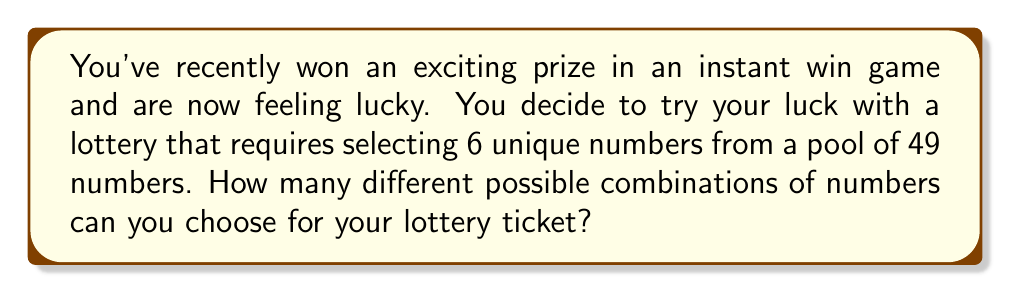Solve this math problem. Let's approach this step-by-step:

1) This is a combination problem because the order of selection doesn't matter (e.g., 1-2-3-4-5-6 is the same combination as 6-5-4-3-2-1).

2) We are selecting 6 numbers out of 49, where each number can only be chosen once.

3) The formula for combinations is:

   $$C(n,r) = \frac{n!}{r!(n-r)!}$$

   Where $n$ is the total number of items to choose from, and $r$ is the number of items being chosen.

4) In this case, $n = 49$ and $r = 6$

5) Plugging these values into our formula:

   $$C(49,6) = \frac{49!}{6!(49-6)!} = \frac{49!}{6!43!}$$

6) Expanding this:

   $$\frac{49 \times 48 \times 47 \times 46 \times 45 \times 44 \times 43!}{(6 \times 5 \times 4 \times 3 \times 2 \times 1) \times 43!}$$

7) The 43! cancels out in the numerator and denominator:

   $$\frac{49 \times 48 \times 47 \times 46 \times 45 \times 44}{6 \times 5 \times 4 \times 3 \times 2 \times 1}$$

8) Calculating this:

   $$\frac{10,068,347,520}{720} = 13,983,816$$

Therefore, there are 13,983,816 possible combinations for your lottery ticket.
Answer: 13,983,816 